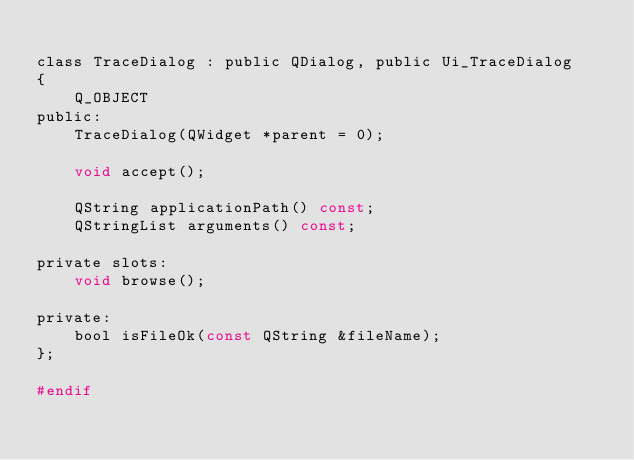<code> <loc_0><loc_0><loc_500><loc_500><_C_>
class TraceDialog : public QDialog, public Ui_TraceDialog
{
    Q_OBJECT
public:
    TraceDialog(QWidget *parent = 0);

    void accept();

    QString applicationPath() const;
    QStringList arguments() const;

private slots:
    void browse();

private:
    bool isFileOk(const QString &fileName);
};

#endif
</code> 